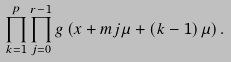Convert formula to latex. <formula><loc_0><loc_0><loc_500><loc_500>\prod ^ { p } _ { k = 1 } { \prod ^ { r - 1 } _ { j = 0 } { g \left ( x + m j \mu + \left ( k - 1 \right ) \mu \right ) . } }</formula> 